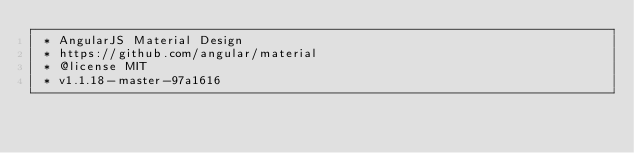<code> <loc_0><loc_0><loc_500><loc_500><_CSS_> * AngularJS Material Design
 * https://github.com/angular/material
 * @license MIT
 * v1.1.18-master-97a1616</code> 